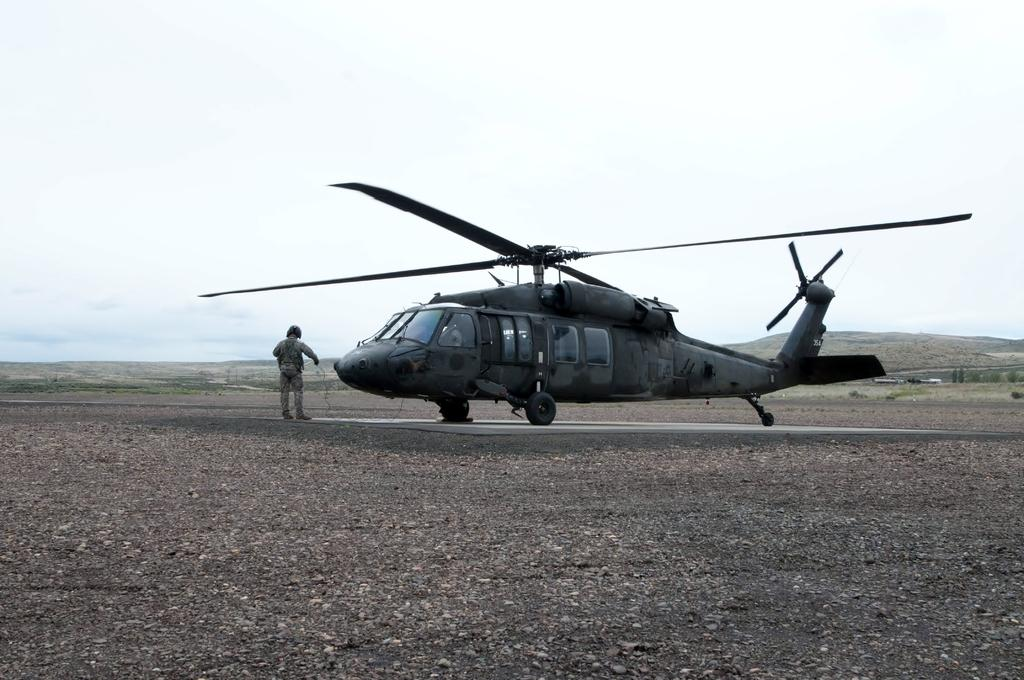What is the main subject of the image? The main subject of the image is a helicopter. Where is the helicopter located in the image? The helicopter is on the ground in the image. Is there anyone near the helicopter? Yes, there is a person in front of the helicopter in the image. How many grapes are being eaten by the deer in the image? There is no deer or grapes present in the image; it features a helicopter on the ground with a person in front of it. 